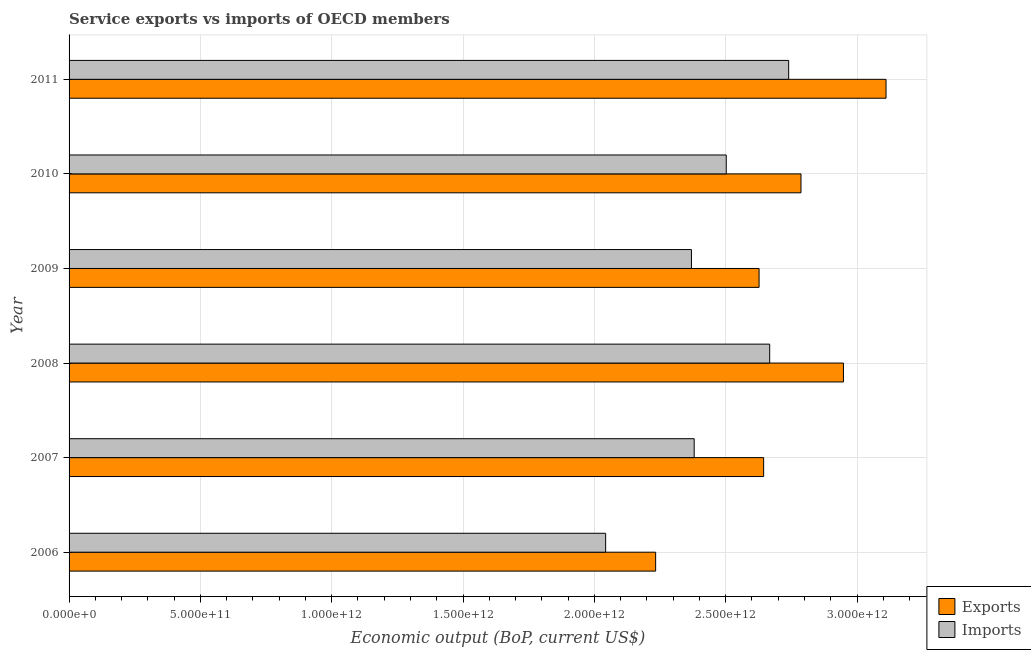How many bars are there on the 3rd tick from the bottom?
Your answer should be compact. 2. What is the label of the 2nd group of bars from the top?
Make the answer very short. 2010. What is the amount of service exports in 2010?
Give a very brief answer. 2.79e+12. Across all years, what is the maximum amount of service imports?
Your response must be concise. 2.74e+12. Across all years, what is the minimum amount of service exports?
Your answer should be compact. 2.23e+12. In which year was the amount of service exports maximum?
Provide a succinct answer. 2011. In which year was the amount of service imports minimum?
Your answer should be compact. 2006. What is the total amount of service imports in the graph?
Provide a short and direct response. 1.47e+13. What is the difference between the amount of service exports in 2007 and that in 2008?
Offer a terse response. -3.04e+11. What is the difference between the amount of service exports in 2009 and the amount of service imports in 2006?
Provide a succinct answer. 5.84e+11. What is the average amount of service exports per year?
Your answer should be very brief. 2.73e+12. In the year 2007, what is the difference between the amount of service imports and amount of service exports?
Provide a succinct answer. -2.64e+11. In how many years, is the amount of service imports greater than 2400000000000 US$?
Your answer should be very brief. 3. What is the ratio of the amount of service imports in 2008 to that in 2010?
Keep it short and to the point. 1.07. Is the difference between the amount of service imports in 2006 and 2007 greater than the difference between the amount of service exports in 2006 and 2007?
Provide a succinct answer. Yes. What is the difference between the highest and the second highest amount of service imports?
Keep it short and to the point. 7.23e+1. What is the difference between the highest and the lowest amount of service exports?
Your answer should be very brief. 8.77e+11. Is the sum of the amount of service imports in 2010 and 2011 greater than the maximum amount of service exports across all years?
Your answer should be compact. Yes. What does the 1st bar from the top in 2009 represents?
Offer a terse response. Imports. What does the 1st bar from the bottom in 2008 represents?
Provide a succinct answer. Exports. How many bars are there?
Make the answer very short. 12. Are all the bars in the graph horizontal?
Offer a terse response. Yes. What is the difference between two consecutive major ticks on the X-axis?
Offer a terse response. 5.00e+11. Are the values on the major ticks of X-axis written in scientific E-notation?
Ensure brevity in your answer.  Yes. Does the graph contain grids?
Keep it short and to the point. Yes. How many legend labels are there?
Offer a terse response. 2. How are the legend labels stacked?
Offer a terse response. Vertical. What is the title of the graph?
Provide a succinct answer. Service exports vs imports of OECD members. What is the label or title of the X-axis?
Provide a succinct answer. Economic output (BoP, current US$). What is the label or title of the Y-axis?
Provide a succinct answer. Year. What is the Economic output (BoP, current US$) in Exports in 2006?
Give a very brief answer. 2.23e+12. What is the Economic output (BoP, current US$) in Imports in 2006?
Offer a terse response. 2.04e+12. What is the Economic output (BoP, current US$) in Exports in 2007?
Ensure brevity in your answer.  2.64e+12. What is the Economic output (BoP, current US$) of Imports in 2007?
Ensure brevity in your answer.  2.38e+12. What is the Economic output (BoP, current US$) in Exports in 2008?
Make the answer very short. 2.95e+12. What is the Economic output (BoP, current US$) of Imports in 2008?
Ensure brevity in your answer.  2.67e+12. What is the Economic output (BoP, current US$) in Exports in 2009?
Your response must be concise. 2.63e+12. What is the Economic output (BoP, current US$) of Imports in 2009?
Give a very brief answer. 2.37e+12. What is the Economic output (BoP, current US$) in Exports in 2010?
Your answer should be compact. 2.79e+12. What is the Economic output (BoP, current US$) of Imports in 2010?
Offer a very short reply. 2.50e+12. What is the Economic output (BoP, current US$) of Exports in 2011?
Your answer should be compact. 3.11e+12. What is the Economic output (BoP, current US$) of Imports in 2011?
Your response must be concise. 2.74e+12. Across all years, what is the maximum Economic output (BoP, current US$) in Exports?
Offer a terse response. 3.11e+12. Across all years, what is the maximum Economic output (BoP, current US$) in Imports?
Provide a short and direct response. 2.74e+12. Across all years, what is the minimum Economic output (BoP, current US$) of Exports?
Your answer should be compact. 2.23e+12. Across all years, what is the minimum Economic output (BoP, current US$) in Imports?
Give a very brief answer. 2.04e+12. What is the total Economic output (BoP, current US$) in Exports in the graph?
Provide a succinct answer. 1.64e+13. What is the total Economic output (BoP, current US$) of Imports in the graph?
Offer a terse response. 1.47e+13. What is the difference between the Economic output (BoP, current US$) in Exports in 2006 and that in 2007?
Provide a short and direct response. -4.11e+11. What is the difference between the Economic output (BoP, current US$) of Imports in 2006 and that in 2007?
Offer a very short reply. -3.37e+11. What is the difference between the Economic output (BoP, current US$) of Exports in 2006 and that in 2008?
Provide a short and direct response. -7.15e+11. What is the difference between the Economic output (BoP, current US$) of Imports in 2006 and that in 2008?
Offer a terse response. -6.25e+11. What is the difference between the Economic output (BoP, current US$) of Exports in 2006 and that in 2009?
Your response must be concise. -3.94e+11. What is the difference between the Economic output (BoP, current US$) of Imports in 2006 and that in 2009?
Your answer should be very brief. -3.27e+11. What is the difference between the Economic output (BoP, current US$) of Exports in 2006 and that in 2010?
Your response must be concise. -5.53e+11. What is the difference between the Economic output (BoP, current US$) of Imports in 2006 and that in 2010?
Offer a very short reply. -4.59e+11. What is the difference between the Economic output (BoP, current US$) in Exports in 2006 and that in 2011?
Offer a very short reply. -8.77e+11. What is the difference between the Economic output (BoP, current US$) of Imports in 2006 and that in 2011?
Your answer should be compact. -6.97e+11. What is the difference between the Economic output (BoP, current US$) of Exports in 2007 and that in 2008?
Make the answer very short. -3.04e+11. What is the difference between the Economic output (BoP, current US$) of Imports in 2007 and that in 2008?
Provide a succinct answer. -2.87e+11. What is the difference between the Economic output (BoP, current US$) in Exports in 2007 and that in 2009?
Offer a very short reply. 1.74e+1. What is the difference between the Economic output (BoP, current US$) in Imports in 2007 and that in 2009?
Your answer should be compact. 1.05e+1. What is the difference between the Economic output (BoP, current US$) of Exports in 2007 and that in 2010?
Your response must be concise. -1.42e+11. What is the difference between the Economic output (BoP, current US$) in Imports in 2007 and that in 2010?
Offer a very short reply. -1.22e+11. What is the difference between the Economic output (BoP, current US$) in Exports in 2007 and that in 2011?
Give a very brief answer. -4.66e+11. What is the difference between the Economic output (BoP, current US$) in Imports in 2007 and that in 2011?
Make the answer very short. -3.60e+11. What is the difference between the Economic output (BoP, current US$) in Exports in 2008 and that in 2009?
Your answer should be very brief. 3.21e+11. What is the difference between the Economic output (BoP, current US$) in Imports in 2008 and that in 2009?
Your answer should be very brief. 2.98e+11. What is the difference between the Economic output (BoP, current US$) in Exports in 2008 and that in 2010?
Ensure brevity in your answer.  1.62e+11. What is the difference between the Economic output (BoP, current US$) in Imports in 2008 and that in 2010?
Keep it short and to the point. 1.65e+11. What is the difference between the Economic output (BoP, current US$) of Exports in 2008 and that in 2011?
Offer a terse response. -1.62e+11. What is the difference between the Economic output (BoP, current US$) of Imports in 2008 and that in 2011?
Give a very brief answer. -7.23e+1. What is the difference between the Economic output (BoP, current US$) of Exports in 2009 and that in 2010?
Offer a terse response. -1.60e+11. What is the difference between the Economic output (BoP, current US$) of Imports in 2009 and that in 2010?
Your answer should be very brief. -1.33e+11. What is the difference between the Economic output (BoP, current US$) in Exports in 2009 and that in 2011?
Provide a short and direct response. -4.83e+11. What is the difference between the Economic output (BoP, current US$) of Imports in 2009 and that in 2011?
Provide a short and direct response. -3.70e+11. What is the difference between the Economic output (BoP, current US$) of Exports in 2010 and that in 2011?
Ensure brevity in your answer.  -3.24e+11. What is the difference between the Economic output (BoP, current US$) in Imports in 2010 and that in 2011?
Make the answer very short. -2.38e+11. What is the difference between the Economic output (BoP, current US$) of Exports in 2006 and the Economic output (BoP, current US$) of Imports in 2007?
Make the answer very short. -1.47e+11. What is the difference between the Economic output (BoP, current US$) of Exports in 2006 and the Economic output (BoP, current US$) of Imports in 2008?
Give a very brief answer. -4.34e+11. What is the difference between the Economic output (BoP, current US$) in Exports in 2006 and the Economic output (BoP, current US$) in Imports in 2009?
Offer a very short reply. -1.36e+11. What is the difference between the Economic output (BoP, current US$) in Exports in 2006 and the Economic output (BoP, current US$) in Imports in 2010?
Ensure brevity in your answer.  -2.69e+11. What is the difference between the Economic output (BoP, current US$) of Exports in 2006 and the Economic output (BoP, current US$) of Imports in 2011?
Make the answer very short. -5.06e+11. What is the difference between the Economic output (BoP, current US$) in Exports in 2007 and the Economic output (BoP, current US$) in Imports in 2008?
Make the answer very short. -2.30e+1. What is the difference between the Economic output (BoP, current US$) in Exports in 2007 and the Economic output (BoP, current US$) in Imports in 2009?
Provide a short and direct response. 2.75e+11. What is the difference between the Economic output (BoP, current US$) of Exports in 2007 and the Economic output (BoP, current US$) of Imports in 2010?
Offer a very short reply. 1.42e+11. What is the difference between the Economic output (BoP, current US$) in Exports in 2007 and the Economic output (BoP, current US$) in Imports in 2011?
Provide a short and direct response. -9.53e+1. What is the difference between the Economic output (BoP, current US$) in Exports in 2008 and the Economic output (BoP, current US$) in Imports in 2009?
Your answer should be compact. 5.79e+11. What is the difference between the Economic output (BoP, current US$) of Exports in 2008 and the Economic output (BoP, current US$) of Imports in 2010?
Ensure brevity in your answer.  4.46e+11. What is the difference between the Economic output (BoP, current US$) of Exports in 2008 and the Economic output (BoP, current US$) of Imports in 2011?
Provide a succinct answer. 2.09e+11. What is the difference between the Economic output (BoP, current US$) of Exports in 2009 and the Economic output (BoP, current US$) of Imports in 2010?
Give a very brief answer. 1.25e+11. What is the difference between the Economic output (BoP, current US$) in Exports in 2009 and the Economic output (BoP, current US$) in Imports in 2011?
Give a very brief answer. -1.13e+11. What is the difference between the Economic output (BoP, current US$) in Exports in 2010 and the Economic output (BoP, current US$) in Imports in 2011?
Your response must be concise. 4.69e+1. What is the average Economic output (BoP, current US$) of Exports per year?
Your answer should be very brief. 2.73e+12. What is the average Economic output (BoP, current US$) in Imports per year?
Keep it short and to the point. 2.45e+12. In the year 2006, what is the difference between the Economic output (BoP, current US$) in Exports and Economic output (BoP, current US$) in Imports?
Your answer should be compact. 1.90e+11. In the year 2007, what is the difference between the Economic output (BoP, current US$) in Exports and Economic output (BoP, current US$) in Imports?
Offer a very short reply. 2.64e+11. In the year 2008, what is the difference between the Economic output (BoP, current US$) in Exports and Economic output (BoP, current US$) in Imports?
Make the answer very short. 2.81e+11. In the year 2009, what is the difference between the Economic output (BoP, current US$) in Exports and Economic output (BoP, current US$) in Imports?
Your answer should be compact. 2.58e+11. In the year 2010, what is the difference between the Economic output (BoP, current US$) in Exports and Economic output (BoP, current US$) in Imports?
Your response must be concise. 2.85e+11. In the year 2011, what is the difference between the Economic output (BoP, current US$) of Exports and Economic output (BoP, current US$) of Imports?
Offer a terse response. 3.71e+11. What is the ratio of the Economic output (BoP, current US$) of Exports in 2006 to that in 2007?
Offer a very short reply. 0.84. What is the ratio of the Economic output (BoP, current US$) in Imports in 2006 to that in 2007?
Provide a succinct answer. 0.86. What is the ratio of the Economic output (BoP, current US$) of Exports in 2006 to that in 2008?
Ensure brevity in your answer.  0.76. What is the ratio of the Economic output (BoP, current US$) of Imports in 2006 to that in 2008?
Your answer should be compact. 0.77. What is the ratio of the Economic output (BoP, current US$) of Exports in 2006 to that in 2009?
Your response must be concise. 0.85. What is the ratio of the Economic output (BoP, current US$) of Imports in 2006 to that in 2009?
Your answer should be compact. 0.86. What is the ratio of the Economic output (BoP, current US$) of Exports in 2006 to that in 2010?
Your answer should be compact. 0.8. What is the ratio of the Economic output (BoP, current US$) of Imports in 2006 to that in 2010?
Provide a succinct answer. 0.82. What is the ratio of the Economic output (BoP, current US$) of Exports in 2006 to that in 2011?
Your response must be concise. 0.72. What is the ratio of the Economic output (BoP, current US$) in Imports in 2006 to that in 2011?
Your answer should be compact. 0.75. What is the ratio of the Economic output (BoP, current US$) in Exports in 2007 to that in 2008?
Give a very brief answer. 0.9. What is the ratio of the Economic output (BoP, current US$) in Imports in 2007 to that in 2008?
Give a very brief answer. 0.89. What is the ratio of the Economic output (BoP, current US$) of Exports in 2007 to that in 2009?
Provide a succinct answer. 1.01. What is the ratio of the Economic output (BoP, current US$) in Exports in 2007 to that in 2010?
Your response must be concise. 0.95. What is the ratio of the Economic output (BoP, current US$) in Imports in 2007 to that in 2010?
Give a very brief answer. 0.95. What is the ratio of the Economic output (BoP, current US$) in Exports in 2007 to that in 2011?
Your response must be concise. 0.85. What is the ratio of the Economic output (BoP, current US$) in Imports in 2007 to that in 2011?
Provide a succinct answer. 0.87. What is the ratio of the Economic output (BoP, current US$) in Exports in 2008 to that in 2009?
Give a very brief answer. 1.12. What is the ratio of the Economic output (BoP, current US$) of Imports in 2008 to that in 2009?
Ensure brevity in your answer.  1.13. What is the ratio of the Economic output (BoP, current US$) of Exports in 2008 to that in 2010?
Provide a succinct answer. 1.06. What is the ratio of the Economic output (BoP, current US$) in Imports in 2008 to that in 2010?
Your answer should be very brief. 1.07. What is the ratio of the Economic output (BoP, current US$) of Exports in 2008 to that in 2011?
Offer a terse response. 0.95. What is the ratio of the Economic output (BoP, current US$) of Imports in 2008 to that in 2011?
Provide a short and direct response. 0.97. What is the ratio of the Economic output (BoP, current US$) of Exports in 2009 to that in 2010?
Provide a succinct answer. 0.94. What is the ratio of the Economic output (BoP, current US$) in Imports in 2009 to that in 2010?
Your answer should be compact. 0.95. What is the ratio of the Economic output (BoP, current US$) of Exports in 2009 to that in 2011?
Offer a terse response. 0.84. What is the ratio of the Economic output (BoP, current US$) of Imports in 2009 to that in 2011?
Offer a very short reply. 0.86. What is the ratio of the Economic output (BoP, current US$) in Exports in 2010 to that in 2011?
Provide a succinct answer. 0.9. What is the ratio of the Economic output (BoP, current US$) in Imports in 2010 to that in 2011?
Make the answer very short. 0.91. What is the difference between the highest and the second highest Economic output (BoP, current US$) of Exports?
Offer a very short reply. 1.62e+11. What is the difference between the highest and the second highest Economic output (BoP, current US$) of Imports?
Your response must be concise. 7.23e+1. What is the difference between the highest and the lowest Economic output (BoP, current US$) of Exports?
Provide a succinct answer. 8.77e+11. What is the difference between the highest and the lowest Economic output (BoP, current US$) of Imports?
Offer a terse response. 6.97e+11. 